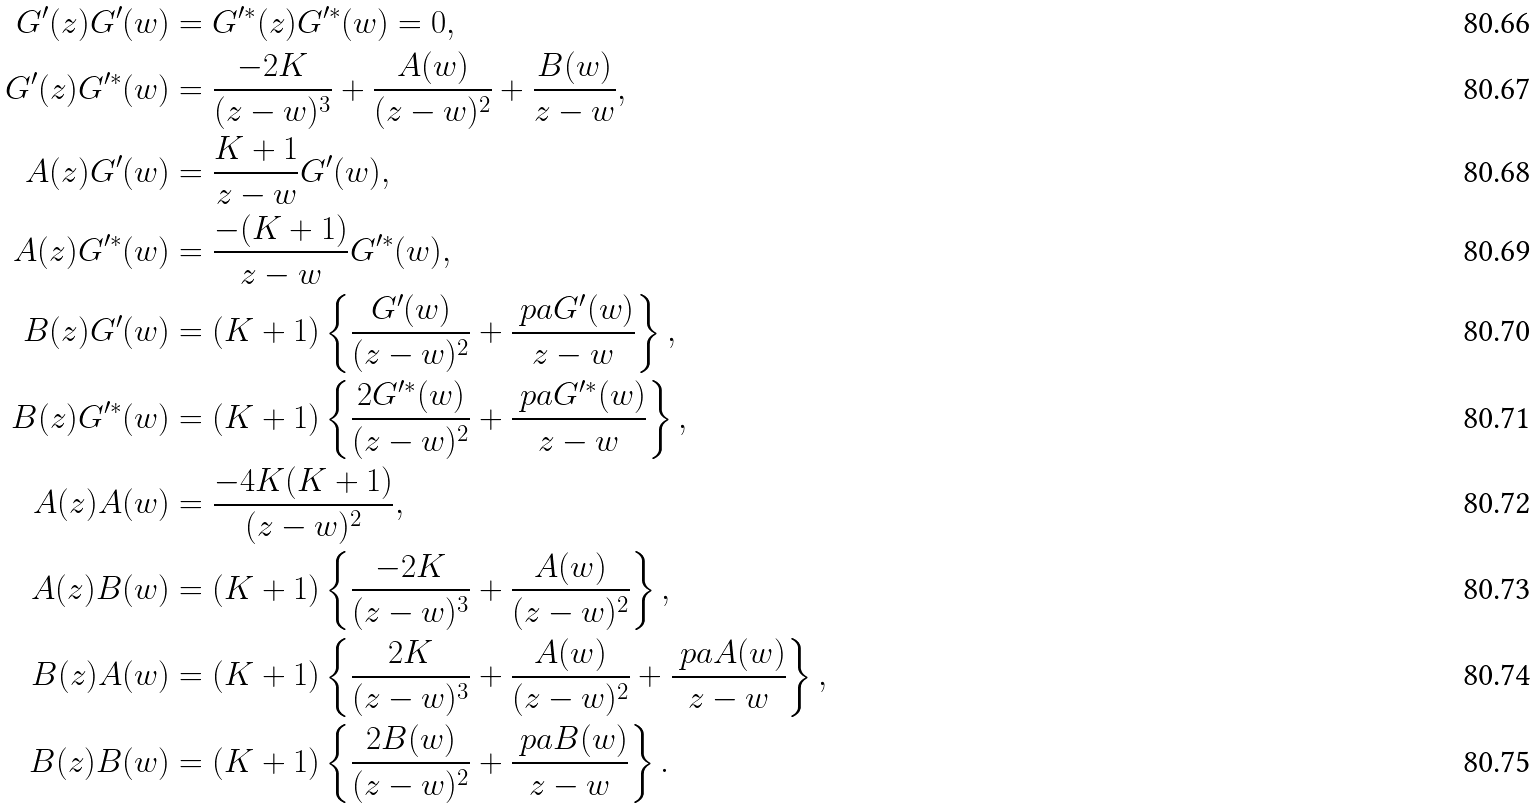Convert formula to latex. <formula><loc_0><loc_0><loc_500><loc_500>G ^ { \prime } ( z ) G ^ { \prime } ( w ) & = G ^ { \prime \ast } ( z ) G ^ { \prime \ast } ( w ) = 0 , \\ G ^ { \prime } ( z ) G ^ { \prime \ast } ( w ) & = \frac { - 2 K } { ( z - w ) ^ { 3 } } + \frac { A ( w ) } { ( z - w ) ^ { 2 } } + \frac { B ( w ) } { z - w } , \\ A ( z ) G ^ { \prime } ( w ) & = \frac { K + 1 } { z - w } G ^ { \prime } ( w ) , \\ A ( z ) G ^ { \prime \ast } ( w ) & = \frac { - ( K + 1 ) } { z - w } G ^ { \prime \ast } ( w ) , \\ B ( z ) G ^ { \prime } ( w ) & = ( K + 1 ) \left \{ \frac { G ^ { \prime } ( w ) } { ( z - w ) ^ { 2 } } + \frac { \ p a G ^ { \prime } ( w ) } { z - w } \right \} , \\ B ( z ) G ^ { \prime \ast } ( w ) & = ( K + 1 ) \left \{ \frac { 2 G ^ { \prime \ast } ( w ) } { ( z - w ) ^ { 2 } } + \frac { \ p a G ^ { \prime \ast } ( w ) } { z - w } \right \} , \\ A ( z ) A ( w ) & = \frac { - 4 K ( K + 1 ) } { ( z - w ) ^ { 2 } } , \\ A ( z ) B ( w ) & = ( K + 1 ) \left \{ \frac { - 2 K } { ( z - w ) ^ { 3 } } + \frac { A ( w ) } { ( z - w ) ^ { 2 } } \right \} , \\ B ( z ) A ( w ) & = ( K + 1 ) \left \{ \frac { 2 K } { ( z - w ) ^ { 3 } } + \frac { A ( w ) } { ( z - w ) ^ { 2 } } + \frac { \ p a A ( w ) } { z - w } \right \} , \\ B ( z ) B ( w ) & = ( K + 1 ) \left \{ \frac { 2 B ( w ) } { ( z - w ) ^ { 2 } } + \frac { \ p a B ( w ) } { z - w } \right \} .</formula> 